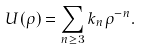<formula> <loc_0><loc_0><loc_500><loc_500>U ( \rho ) = \sum _ { n \geq 3 } k _ { n } \rho ^ { - n } .</formula> 